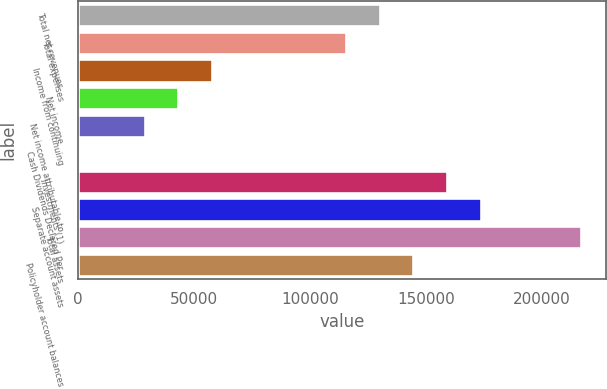Convert chart. <chart><loc_0><loc_0><loc_500><loc_500><bar_chart><fcel>Total net revenues<fcel>Total expenses<fcel>Income from continuing<fcel>Net income<fcel>Net income attributable to<fcel>Cash Dividends Declared Per<fcel>Investments (1)<fcel>Separate account assets<fcel>Total assets<fcel>Policyholder account balances<nl><fcel>130109<fcel>115652<fcel>57827.2<fcel>43370.9<fcel>28914.6<fcel>2.01<fcel>159021<fcel>173478<fcel>216847<fcel>144565<nl></chart> 